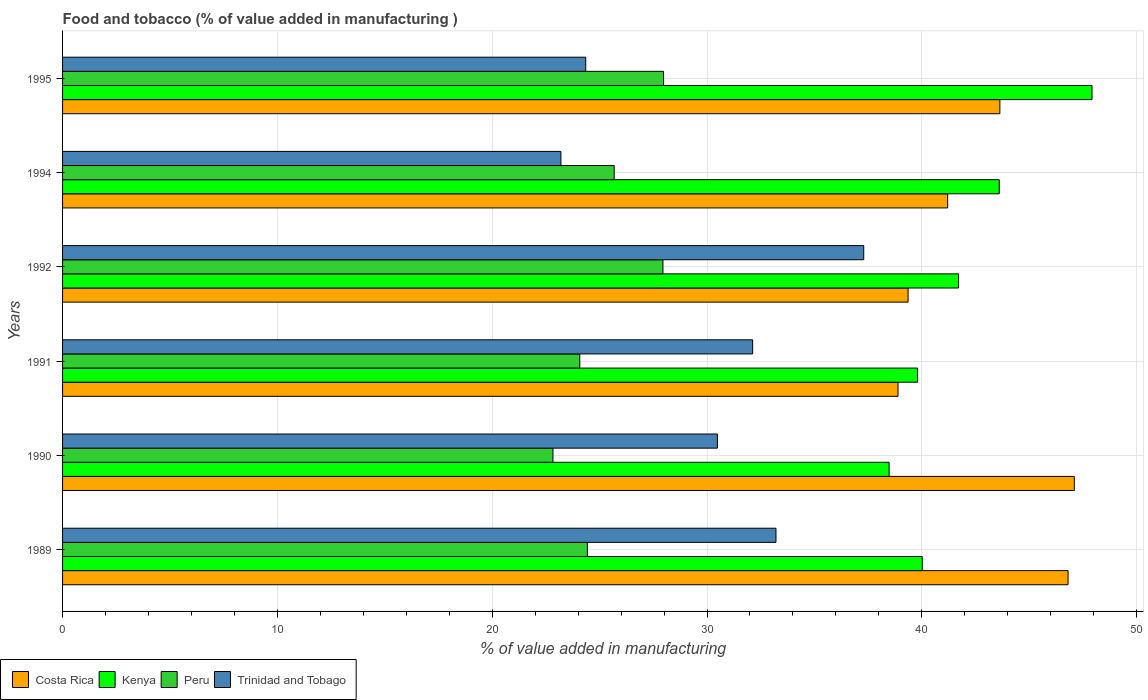How many bars are there on the 4th tick from the bottom?
Keep it short and to the point. 4. What is the label of the 1st group of bars from the top?
Your answer should be very brief. 1995. What is the value added in manufacturing food and tobacco in Trinidad and Tobago in 1989?
Provide a succinct answer. 33.21. Across all years, what is the maximum value added in manufacturing food and tobacco in Peru?
Offer a very short reply. 27.98. Across all years, what is the minimum value added in manufacturing food and tobacco in Peru?
Provide a short and direct response. 22.83. In which year was the value added in manufacturing food and tobacco in Peru minimum?
Your answer should be very brief. 1990. What is the total value added in manufacturing food and tobacco in Trinidad and Tobago in the graph?
Offer a terse response. 180.67. What is the difference between the value added in manufacturing food and tobacco in Costa Rica in 1991 and that in 1994?
Your answer should be very brief. -2.31. What is the difference between the value added in manufacturing food and tobacco in Kenya in 1991 and the value added in manufacturing food and tobacco in Trinidad and Tobago in 1989?
Make the answer very short. 6.59. What is the average value added in manufacturing food and tobacco in Peru per year?
Your response must be concise. 25.49. In the year 1995, what is the difference between the value added in manufacturing food and tobacco in Costa Rica and value added in manufacturing food and tobacco in Peru?
Offer a terse response. 15.66. What is the ratio of the value added in manufacturing food and tobacco in Costa Rica in 1992 to that in 1994?
Offer a very short reply. 0.96. Is the value added in manufacturing food and tobacco in Costa Rica in 1990 less than that in 1992?
Your answer should be very brief. No. Is the difference between the value added in manufacturing food and tobacco in Costa Rica in 1990 and 1995 greater than the difference between the value added in manufacturing food and tobacco in Peru in 1990 and 1995?
Offer a very short reply. Yes. What is the difference between the highest and the second highest value added in manufacturing food and tobacco in Peru?
Offer a terse response. 0.03. What is the difference between the highest and the lowest value added in manufacturing food and tobacco in Peru?
Offer a terse response. 5.15. In how many years, is the value added in manufacturing food and tobacco in Kenya greater than the average value added in manufacturing food and tobacco in Kenya taken over all years?
Your response must be concise. 2. Is the sum of the value added in manufacturing food and tobacco in Peru in 1992 and 1994 greater than the maximum value added in manufacturing food and tobacco in Costa Rica across all years?
Offer a very short reply. Yes. Is it the case that in every year, the sum of the value added in manufacturing food and tobacco in Costa Rica and value added in manufacturing food and tobacco in Trinidad and Tobago is greater than the sum of value added in manufacturing food and tobacco in Kenya and value added in manufacturing food and tobacco in Peru?
Give a very brief answer. Yes. What does the 4th bar from the top in 1995 represents?
Provide a succinct answer. Costa Rica. What does the 1st bar from the bottom in 1995 represents?
Your response must be concise. Costa Rica. Is it the case that in every year, the sum of the value added in manufacturing food and tobacco in Costa Rica and value added in manufacturing food and tobacco in Trinidad and Tobago is greater than the value added in manufacturing food and tobacco in Peru?
Offer a terse response. Yes. How many bars are there?
Make the answer very short. 24. Are the values on the major ticks of X-axis written in scientific E-notation?
Provide a short and direct response. No. Does the graph contain grids?
Your answer should be very brief. Yes. How many legend labels are there?
Your answer should be compact. 4. What is the title of the graph?
Ensure brevity in your answer.  Food and tobacco (% of value added in manufacturing ). Does "Other small states" appear as one of the legend labels in the graph?
Provide a succinct answer. No. What is the label or title of the X-axis?
Your answer should be compact. % of value added in manufacturing. What is the % of value added in manufacturing of Costa Rica in 1989?
Your answer should be very brief. 46.81. What is the % of value added in manufacturing of Kenya in 1989?
Ensure brevity in your answer.  40.02. What is the % of value added in manufacturing in Peru in 1989?
Keep it short and to the point. 24.43. What is the % of value added in manufacturing in Trinidad and Tobago in 1989?
Make the answer very short. 33.21. What is the % of value added in manufacturing of Costa Rica in 1990?
Make the answer very short. 47.1. What is the % of value added in manufacturing of Kenya in 1990?
Ensure brevity in your answer.  38.48. What is the % of value added in manufacturing in Peru in 1990?
Give a very brief answer. 22.83. What is the % of value added in manufacturing of Trinidad and Tobago in 1990?
Ensure brevity in your answer.  30.48. What is the % of value added in manufacturing in Costa Rica in 1991?
Give a very brief answer. 38.89. What is the % of value added in manufacturing of Kenya in 1991?
Ensure brevity in your answer.  39.8. What is the % of value added in manufacturing of Peru in 1991?
Keep it short and to the point. 24.08. What is the % of value added in manufacturing in Trinidad and Tobago in 1991?
Your answer should be compact. 32.13. What is the % of value added in manufacturing of Costa Rica in 1992?
Give a very brief answer. 39.36. What is the % of value added in manufacturing of Kenya in 1992?
Provide a succinct answer. 41.71. What is the % of value added in manufacturing in Peru in 1992?
Your answer should be compact. 27.95. What is the % of value added in manufacturing of Trinidad and Tobago in 1992?
Make the answer very short. 37.3. What is the % of value added in manufacturing in Costa Rica in 1994?
Ensure brevity in your answer.  41.2. What is the % of value added in manufacturing in Kenya in 1994?
Your answer should be compact. 43.6. What is the % of value added in manufacturing in Peru in 1994?
Offer a very short reply. 25.68. What is the % of value added in manufacturing of Trinidad and Tobago in 1994?
Make the answer very short. 23.2. What is the % of value added in manufacturing of Costa Rica in 1995?
Make the answer very short. 43.63. What is the % of value added in manufacturing of Kenya in 1995?
Keep it short and to the point. 47.92. What is the % of value added in manufacturing of Peru in 1995?
Your answer should be very brief. 27.98. What is the % of value added in manufacturing of Trinidad and Tobago in 1995?
Provide a short and direct response. 24.35. Across all years, what is the maximum % of value added in manufacturing of Costa Rica?
Offer a terse response. 47.1. Across all years, what is the maximum % of value added in manufacturing in Kenya?
Your answer should be very brief. 47.92. Across all years, what is the maximum % of value added in manufacturing of Peru?
Keep it short and to the point. 27.98. Across all years, what is the maximum % of value added in manufacturing of Trinidad and Tobago?
Ensure brevity in your answer.  37.3. Across all years, what is the minimum % of value added in manufacturing in Costa Rica?
Your answer should be compact. 38.89. Across all years, what is the minimum % of value added in manufacturing in Kenya?
Your answer should be very brief. 38.48. Across all years, what is the minimum % of value added in manufacturing in Peru?
Keep it short and to the point. 22.83. Across all years, what is the minimum % of value added in manufacturing in Trinidad and Tobago?
Ensure brevity in your answer.  23.2. What is the total % of value added in manufacturing of Costa Rica in the graph?
Offer a very short reply. 257. What is the total % of value added in manufacturing of Kenya in the graph?
Your response must be concise. 251.54. What is the total % of value added in manufacturing of Peru in the graph?
Ensure brevity in your answer.  152.94. What is the total % of value added in manufacturing of Trinidad and Tobago in the graph?
Give a very brief answer. 180.67. What is the difference between the % of value added in manufacturing of Costa Rica in 1989 and that in 1990?
Your answer should be very brief. -0.29. What is the difference between the % of value added in manufacturing of Kenya in 1989 and that in 1990?
Ensure brevity in your answer.  1.54. What is the difference between the % of value added in manufacturing in Peru in 1989 and that in 1990?
Your answer should be very brief. 1.6. What is the difference between the % of value added in manufacturing in Trinidad and Tobago in 1989 and that in 1990?
Give a very brief answer. 2.73. What is the difference between the % of value added in manufacturing in Costa Rica in 1989 and that in 1991?
Make the answer very short. 7.92. What is the difference between the % of value added in manufacturing in Kenya in 1989 and that in 1991?
Provide a short and direct response. 0.22. What is the difference between the % of value added in manufacturing of Peru in 1989 and that in 1991?
Offer a very short reply. 0.35. What is the difference between the % of value added in manufacturing of Trinidad and Tobago in 1989 and that in 1991?
Offer a terse response. 1.08. What is the difference between the % of value added in manufacturing in Costa Rica in 1989 and that in 1992?
Your answer should be very brief. 7.45. What is the difference between the % of value added in manufacturing in Kenya in 1989 and that in 1992?
Provide a short and direct response. -1.69. What is the difference between the % of value added in manufacturing of Peru in 1989 and that in 1992?
Keep it short and to the point. -3.52. What is the difference between the % of value added in manufacturing in Trinidad and Tobago in 1989 and that in 1992?
Your answer should be very brief. -4.09. What is the difference between the % of value added in manufacturing in Costa Rica in 1989 and that in 1994?
Your answer should be compact. 5.6. What is the difference between the % of value added in manufacturing in Kenya in 1989 and that in 1994?
Your response must be concise. -3.59. What is the difference between the % of value added in manufacturing of Peru in 1989 and that in 1994?
Keep it short and to the point. -1.25. What is the difference between the % of value added in manufacturing in Trinidad and Tobago in 1989 and that in 1994?
Offer a very short reply. 10.01. What is the difference between the % of value added in manufacturing in Costa Rica in 1989 and that in 1995?
Keep it short and to the point. 3.17. What is the difference between the % of value added in manufacturing of Kenya in 1989 and that in 1995?
Offer a very short reply. -7.9. What is the difference between the % of value added in manufacturing of Peru in 1989 and that in 1995?
Offer a terse response. -3.55. What is the difference between the % of value added in manufacturing in Trinidad and Tobago in 1989 and that in 1995?
Offer a very short reply. 8.86. What is the difference between the % of value added in manufacturing of Costa Rica in 1990 and that in 1991?
Keep it short and to the point. 8.21. What is the difference between the % of value added in manufacturing of Kenya in 1990 and that in 1991?
Your answer should be compact. -1.33. What is the difference between the % of value added in manufacturing of Peru in 1990 and that in 1991?
Give a very brief answer. -1.25. What is the difference between the % of value added in manufacturing in Trinidad and Tobago in 1990 and that in 1991?
Keep it short and to the point. -1.64. What is the difference between the % of value added in manufacturing in Costa Rica in 1990 and that in 1992?
Make the answer very short. 7.74. What is the difference between the % of value added in manufacturing of Kenya in 1990 and that in 1992?
Provide a short and direct response. -3.23. What is the difference between the % of value added in manufacturing in Peru in 1990 and that in 1992?
Make the answer very short. -5.12. What is the difference between the % of value added in manufacturing of Trinidad and Tobago in 1990 and that in 1992?
Your answer should be very brief. -6.81. What is the difference between the % of value added in manufacturing in Costa Rica in 1990 and that in 1994?
Keep it short and to the point. 5.89. What is the difference between the % of value added in manufacturing of Kenya in 1990 and that in 1994?
Your answer should be compact. -5.13. What is the difference between the % of value added in manufacturing of Peru in 1990 and that in 1994?
Offer a very short reply. -2.85. What is the difference between the % of value added in manufacturing in Trinidad and Tobago in 1990 and that in 1994?
Offer a very short reply. 7.29. What is the difference between the % of value added in manufacturing in Costa Rica in 1990 and that in 1995?
Provide a succinct answer. 3.46. What is the difference between the % of value added in manufacturing in Kenya in 1990 and that in 1995?
Ensure brevity in your answer.  -9.45. What is the difference between the % of value added in manufacturing in Peru in 1990 and that in 1995?
Ensure brevity in your answer.  -5.15. What is the difference between the % of value added in manufacturing of Trinidad and Tobago in 1990 and that in 1995?
Ensure brevity in your answer.  6.13. What is the difference between the % of value added in manufacturing in Costa Rica in 1991 and that in 1992?
Provide a short and direct response. -0.47. What is the difference between the % of value added in manufacturing in Kenya in 1991 and that in 1992?
Offer a very short reply. -1.91. What is the difference between the % of value added in manufacturing of Peru in 1991 and that in 1992?
Ensure brevity in your answer.  -3.87. What is the difference between the % of value added in manufacturing in Trinidad and Tobago in 1991 and that in 1992?
Make the answer very short. -5.17. What is the difference between the % of value added in manufacturing of Costa Rica in 1991 and that in 1994?
Offer a terse response. -2.31. What is the difference between the % of value added in manufacturing in Kenya in 1991 and that in 1994?
Offer a very short reply. -3.8. What is the difference between the % of value added in manufacturing of Peru in 1991 and that in 1994?
Provide a short and direct response. -1.6. What is the difference between the % of value added in manufacturing of Trinidad and Tobago in 1991 and that in 1994?
Your answer should be very brief. 8.93. What is the difference between the % of value added in manufacturing in Costa Rica in 1991 and that in 1995?
Provide a succinct answer. -4.74. What is the difference between the % of value added in manufacturing of Kenya in 1991 and that in 1995?
Offer a very short reply. -8.12. What is the difference between the % of value added in manufacturing of Peru in 1991 and that in 1995?
Keep it short and to the point. -3.9. What is the difference between the % of value added in manufacturing of Trinidad and Tobago in 1991 and that in 1995?
Offer a terse response. 7.77. What is the difference between the % of value added in manufacturing of Costa Rica in 1992 and that in 1994?
Offer a terse response. -1.84. What is the difference between the % of value added in manufacturing of Kenya in 1992 and that in 1994?
Offer a very short reply. -1.89. What is the difference between the % of value added in manufacturing in Peru in 1992 and that in 1994?
Your answer should be very brief. 2.27. What is the difference between the % of value added in manufacturing of Trinidad and Tobago in 1992 and that in 1994?
Your response must be concise. 14.1. What is the difference between the % of value added in manufacturing in Costa Rica in 1992 and that in 1995?
Offer a terse response. -4.27. What is the difference between the % of value added in manufacturing in Kenya in 1992 and that in 1995?
Provide a short and direct response. -6.21. What is the difference between the % of value added in manufacturing of Peru in 1992 and that in 1995?
Your response must be concise. -0.03. What is the difference between the % of value added in manufacturing in Trinidad and Tobago in 1992 and that in 1995?
Give a very brief answer. 12.94. What is the difference between the % of value added in manufacturing in Costa Rica in 1994 and that in 1995?
Your answer should be compact. -2.43. What is the difference between the % of value added in manufacturing of Kenya in 1994 and that in 1995?
Ensure brevity in your answer.  -4.32. What is the difference between the % of value added in manufacturing of Peru in 1994 and that in 1995?
Give a very brief answer. -2.3. What is the difference between the % of value added in manufacturing of Trinidad and Tobago in 1994 and that in 1995?
Make the answer very short. -1.16. What is the difference between the % of value added in manufacturing in Costa Rica in 1989 and the % of value added in manufacturing in Kenya in 1990?
Provide a succinct answer. 8.33. What is the difference between the % of value added in manufacturing of Costa Rica in 1989 and the % of value added in manufacturing of Peru in 1990?
Ensure brevity in your answer.  23.98. What is the difference between the % of value added in manufacturing in Costa Rica in 1989 and the % of value added in manufacturing in Trinidad and Tobago in 1990?
Keep it short and to the point. 16.32. What is the difference between the % of value added in manufacturing of Kenya in 1989 and the % of value added in manufacturing of Peru in 1990?
Provide a succinct answer. 17.19. What is the difference between the % of value added in manufacturing in Kenya in 1989 and the % of value added in manufacturing in Trinidad and Tobago in 1990?
Your response must be concise. 9.53. What is the difference between the % of value added in manufacturing in Peru in 1989 and the % of value added in manufacturing in Trinidad and Tobago in 1990?
Provide a succinct answer. -6.05. What is the difference between the % of value added in manufacturing of Costa Rica in 1989 and the % of value added in manufacturing of Kenya in 1991?
Your response must be concise. 7. What is the difference between the % of value added in manufacturing of Costa Rica in 1989 and the % of value added in manufacturing of Peru in 1991?
Give a very brief answer. 22.73. What is the difference between the % of value added in manufacturing in Costa Rica in 1989 and the % of value added in manufacturing in Trinidad and Tobago in 1991?
Make the answer very short. 14.68. What is the difference between the % of value added in manufacturing of Kenya in 1989 and the % of value added in manufacturing of Peru in 1991?
Keep it short and to the point. 15.94. What is the difference between the % of value added in manufacturing of Kenya in 1989 and the % of value added in manufacturing of Trinidad and Tobago in 1991?
Give a very brief answer. 7.89. What is the difference between the % of value added in manufacturing of Peru in 1989 and the % of value added in manufacturing of Trinidad and Tobago in 1991?
Keep it short and to the point. -7.7. What is the difference between the % of value added in manufacturing of Costa Rica in 1989 and the % of value added in manufacturing of Kenya in 1992?
Ensure brevity in your answer.  5.1. What is the difference between the % of value added in manufacturing in Costa Rica in 1989 and the % of value added in manufacturing in Peru in 1992?
Provide a short and direct response. 18.86. What is the difference between the % of value added in manufacturing of Costa Rica in 1989 and the % of value added in manufacturing of Trinidad and Tobago in 1992?
Make the answer very short. 9.51. What is the difference between the % of value added in manufacturing of Kenya in 1989 and the % of value added in manufacturing of Peru in 1992?
Offer a very short reply. 12.07. What is the difference between the % of value added in manufacturing in Kenya in 1989 and the % of value added in manufacturing in Trinidad and Tobago in 1992?
Ensure brevity in your answer.  2.72. What is the difference between the % of value added in manufacturing of Peru in 1989 and the % of value added in manufacturing of Trinidad and Tobago in 1992?
Your answer should be compact. -12.87. What is the difference between the % of value added in manufacturing in Costa Rica in 1989 and the % of value added in manufacturing in Kenya in 1994?
Give a very brief answer. 3.2. What is the difference between the % of value added in manufacturing of Costa Rica in 1989 and the % of value added in manufacturing of Peru in 1994?
Offer a very short reply. 21.13. What is the difference between the % of value added in manufacturing in Costa Rica in 1989 and the % of value added in manufacturing in Trinidad and Tobago in 1994?
Make the answer very short. 23.61. What is the difference between the % of value added in manufacturing in Kenya in 1989 and the % of value added in manufacturing in Peru in 1994?
Make the answer very short. 14.34. What is the difference between the % of value added in manufacturing in Kenya in 1989 and the % of value added in manufacturing in Trinidad and Tobago in 1994?
Ensure brevity in your answer.  16.82. What is the difference between the % of value added in manufacturing in Peru in 1989 and the % of value added in manufacturing in Trinidad and Tobago in 1994?
Your answer should be very brief. 1.23. What is the difference between the % of value added in manufacturing of Costa Rica in 1989 and the % of value added in manufacturing of Kenya in 1995?
Offer a terse response. -1.12. What is the difference between the % of value added in manufacturing of Costa Rica in 1989 and the % of value added in manufacturing of Peru in 1995?
Ensure brevity in your answer.  18.83. What is the difference between the % of value added in manufacturing of Costa Rica in 1989 and the % of value added in manufacturing of Trinidad and Tobago in 1995?
Your answer should be very brief. 22.45. What is the difference between the % of value added in manufacturing in Kenya in 1989 and the % of value added in manufacturing in Peru in 1995?
Provide a short and direct response. 12.04. What is the difference between the % of value added in manufacturing of Kenya in 1989 and the % of value added in manufacturing of Trinidad and Tobago in 1995?
Offer a terse response. 15.66. What is the difference between the % of value added in manufacturing in Peru in 1989 and the % of value added in manufacturing in Trinidad and Tobago in 1995?
Make the answer very short. 0.07. What is the difference between the % of value added in manufacturing of Costa Rica in 1990 and the % of value added in manufacturing of Kenya in 1991?
Offer a very short reply. 7.29. What is the difference between the % of value added in manufacturing of Costa Rica in 1990 and the % of value added in manufacturing of Peru in 1991?
Your answer should be compact. 23.02. What is the difference between the % of value added in manufacturing in Costa Rica in 1990 and the % of value added in manufacturing in Trinidad and Tobago in 1991?
Give a very brief answer. 14.97. What is the difference between the % of value added in manufacturing in Kenya in 1990 and the % of value added in manufacturing in Trinidad and Tobago in 1991?
Make the answer very short. 6.35. What is the difference between the % of value added in manufacturing of Peru in 1990 and the % of value added in manufacturing of Trinidad and Tobago in 1991?
Offer a very short reply. -9.3. What is the difference between the % of value added in manufacturing of Costa Rica in 1990 and the % of value added in manufacturing of Kenya in 1992?
Offer a terse response. 5.39. What is the difference between the % of value added in manufacturing of Costa Rica in 1990 and the % of value added in manufacturing of Peru in 1992?
Keep it short and to the point. 19.15. What is the difference between the % of value added in manufacturing of Costa Rica in 1990 and the % of value added in manufacturing of Trinidad and Tobago in 1992?
Your response must be concise. 9.8. What is the difference between the % of value added in manufacturing in Kenya in 1990 and the % of value added in manufacturing in Peru in 1992?
Ensure brevity in your answer.  10.53. What is the difference between the % of value added in manufacturing of Kenya in 1990 and the % of value added in manufacturing of Trinidad and Tobago in 1992?
Your answer should be compact. 1.18. What is the difference between the % of value added in manufacturing of Peru in 1990 and the % of value added in manufacturing of Trinidad and Tobago in 1992?
Give a very brief answer. -14.47. What is the difference between the % of value added in manufacturing in Costa Rica in 1990 and the % of value added in manufacturing in Kenya in 1994?
Your answer should be compact. 3.49. What is the difference between the % of value added in manufacturing of Costa Rica in 1990 and the % of value added in manufacturing of Peru in 1994?
Your answer should be very brief. 21.42. What is the difference between the % of value added in manufacturing in Costa Rica in 1990 and the % of value added in manufacturing in Trinidad and Tobago in 1994?
Give a very brief answer. 23.9. What is the difference between the % of value added in manufacturing in Kenya in 1990 and the % of value added in manufacturing in Peru in 1994?
Offer a very short reply. 12.8. What is the difference between the % of value added in manufacturing in Kenya in 1990 and the % of value added in manufacturing in Trinidad and Tobago in 1994?
Offer a very short reply. 15.28. What is the difference between the % of value added in manufacturing in Peru in 1990 and the % of value added in manufacturing in Trinidad and Tobago in 1994?
Ensure brevity in your answer.  -0.37. What is the difference between the % of value added in manufacturing of Costa Rica in 1990 and the % of value added in manufacturing of Kenya in 1995?
Your response must be concise. -0.83. What is the difference between the % of value added in manufacturing in Costa Rica in 1990 and the % of value added in manufacturing in Peru in 1995?
Keep it short and to the point. 19.12. What is the difference between the % of value added in manufacturing in Costa Rica in 1990 and the % of value added in manufacturing in Trinidad and Tobago in 1995?
Provide a succinct answer. 22.74. What is the difference between the % of value added in manufacturing in Kenya in 1990 and the % of value added in manufacturing in Peru in 1995?
Ensure brevity in your answer.  10.5. What is the difference between the % of value added in manufacturing of Kenya in 1990 and the % of value added in manufacturing of Trinidad and Tobago in 1995?
Provide a short and direct response. 14.12. What is the difference between the % of value added in manufacturing in Peru in 1990 and the % of value added in manufacturing in Trinidad and Tobago in 1995?
Give a very brief answer. -1.53. What is the difference between the % of value added in manufacturing of Costa Rica in 1991 and the % of value added in manufacturing of Kenya in 1992?
Offer a terse response. -2.82. What is the difference between the % of value added in manufacturing of Costa Rica in 1991 and the % of value added in manufacturing of Peru in 1992?
Your answer should be compact. 10.94. What is the difference between the % of value added in manufacturing of Costa Rica in 1991 and the % of value added in manufacturing of Trinidad and Tobago in 1992?
Offer a very short reply. 1.6. What is the difference between the % of value added in manufacturing of Kenya in 1991 and the % of value added in manufacturing of Peru in 1992?
Provide a short and direct response. 11.85. What is the difference between the % of value added in manufacturing of Kenya in 1991 and the % of value added in manufacturing of Trinidad and Tobago in 1992?
Offer a very short reply. 2.51. What is the difference between the % of value added in manufacturing in Peru in 1991 and the % of value added in manufacturing in Trinidad and Tobago in 1992?
Offer a terse response. -13.22. What is the difference between the % of value added in manufacturing in Costa Rica in 1991 and the % of value added in manufacturing in Kenya in 1994?
Provide a succinct answer. -4.71. What is the difference between the % of value added in manufacturing of Costa Rica in 1991 and the % of value added in manufacturing of Peru in 1994?
Offer a terse response. 13.21. What is the difference between the % of value added in manufacturing of Costa Rica in 1991 and the % of value added in manufacturing of Trinidad and Tobago in 1994?
Provide a short and direct response. 15.69. What is the difference between the % of value added in manufacturing of Kenya in 1991 and the % of value added in manufacturing of Peru in 1994?
Offer a terse response. 14.12. What is the difference between the % of value added in manufacturing of Kenya in 1991 and the % of value added in manufacturing of Trinidad and Tobago in 1994?
Offer a very short reply. 16.6. What is the difference between the % of value added in manufacturing in Peru in 1991 and the % of value added in manufacturing in Trinidad and Tobago in 1994?
Provide a succinct answer. 0.88. What is the difference between the % of value added in manufacturing of Costa Rica in 1991 and the % of value added in manufacturing of Kenya in 1995?
Give a very brief answer. -9.03. What is the difference between the % of value added in manufacturing of Costa Rica in 1991 and the % of value added in manufacturing of Peru in 1995?
Offer a terse response. 10.91. What is the difference between the % of value added in manufacturing of Costa Rica in 1991 and the % of value added in manufacturing of Trinidad and Tobago in 1995?
Provide a short and direct response. 14.54. What is the difference between the % of value added in manufacturing in Kenya in 1991 and the % of value added in manufacturing in Peru in 1995?
Offer a very short reply. 11.83. What is the difference between the % of value added in manufacturing in Kenya in 1991 and the % of value added in manufacturing in Trinidad and Tobago in 1995?
Provide a succinct answer. 15.45. What is the difference between the % of value added in manufacturing in Peru in 1991 and the % of value added in manufacturing in Trinidad and Tobago in 1995?
Offer a very short reply. -0.28. What is the difference between the % of value added in manufacturing in Costa Rica in 1992 and the % of value added in manufacturing in Kenya in 1994?
Your answer should be compact. -4.24. What is the difference between the % of value added in manufacturing of Costa Rica in 1992 and the % of value added in manufacturing of Peru in 1994?
Make the answer very short. 13.68. What is the difference between the % of value added in manufacturing in Costa Rica in 1992 and the % of value added in manufacturing in Trinidad and Tobago in 1994?
Keep it short and to the point. 16.16. What is the difference between the % of value added in manufacturing in Kenya in 1992 and the % of value added in manufacturing in Peru in 1994?
Offer a very short reply. 16.03. What is the difference between the % of value added in manufacturing in Kenya in 1992 and the % of value added in manufacturing in Trinidad and Tobago in 1994?
Provide a succinct answer. 18.51. What is the difference between the % of value added in manufacturing in Peru in 1992 and the % of value added in manufacturing in Trinidad and Tobago in 1994?
Offer a terse response. 4.75. What is the difference between the % of value added in manufacturing of Costa Rica in 1992 and the % of value added in manufacturing of Kenya in 1995?
Provide a succinct answer. -8.56. What is the difference between the % of value added in manufacturing of Costa Rica in 1992 and the % of value added in manufacturing of Peru in 1995?
Your response must be concise. 11.38. What is the difference between the % of value added in manufacturing of Costa Rica in 1992 and the % of value added in manufacturing of Trinidad and Tobago in 1995?
Your response must be concise. 15.01. What is the difference between the % of value added in manufacturing in Kenya in 1992 and the % of value added in manufacturing in Peru in 1995?
Your response must be concise. 13.73. What is the difference between the % of value added in manufacturing of Kenya in 1992 and the % of value added in manufacturing of Trinidad and Tobago in 1995?
Your answer should be very brief. 17.36. What is the difference between the % of value added in manufacturing in Peru in 1992 and the % of value added in manufacturing in Trinidad and Tobago in 1995?
Your answer should be very brief. 3.59. What is the difference between the % of value added in manufacturing in Costa Rica in 1994 and the % of value added in manufacturing in Kenya in 1995?
Your answer should be compact. -6.72. What is the difference between the % of value added in manufacturing in Costa Rica in 1994 and the % of value added in manufacturing in Peru in 1995?
Your answer should be very brief. 13.23. What is the difference between the % of value added in manufacturing of Costa Rica in 1994 and the % of value added in manufacturing of Trinidad and Tobago in 1995?
Make the answer very short. 16.85. What is the difference between the % of value added in manufacturing of Kenya in 1994 and the % of value added in manufacturing of Peru in 1995?
Offer a terse response. 15.63. What is the difference between the % of value added in manufacturing of Kenya in 1994 and the % of value added in manufacturing of Trinidad and Tobago in 1995?
Your answer should be very brief. 19.25. What is the difference between the % of value added in manufacturing in Peru in 1994 and the % of value added in manufacturing in Trinidad and Tobago in 1995?
Provide a short and direct response. 1.32. What is the average % of value added in manufacturing in Costa Rica per year?
Ensure brevity in your answer.  42.83. What is the average % of value added in manufacturing in Kenya per year?
Provide a succinct answer. 41.92. What is the average % of value added in manufacturing of Peru per year?
Provide a short and direct response. 25.49. What is the average % of value added in manufacturing in Trinidad and Tobago per year?
Your response must be concise. 30.11. In the year 1989, what is the difference between the % of value added in manufacturing of Costa Rica and % of value added in manufacturing of Kenya?
Offer a terse response. 6.79. In the year 1989, what is the difference between the % of value added in manufacturing in Costa Rica and % of value added in manufacturing in Peru?
Make the answer very short. 22.38. In the year 1989, what is the difference between the % of value added in manufacturing of Costa Rica and % of value added in manufacturing of Trinidad and Tobago?
Offer a very short reply. 13.6. In the year 1989, what is the difference between the % of value added in manufacturing of Kenya and % of value added in manufacturing of Peru?
Your response must be concise. 15.59. In the year 1989, what is the difference between the % of value added in manufacturing of Kenya and % of value added in manufacturing of Trinidad and Tobago?
Offer a very short reply. 6.81. In the year 1989, what is the difference between the % of value added in manufacturing of Peru and % of value added in manufacturing of Trinidad and Tobago?
Make the answer very short. -8.78. In the year 1990, what is the difference between the % of value added in manufacturing in Costa Rica and % of value added in manufacturing in Kenya?
Provide a short and direct response. 8.62. In the year 1990, what is the difference between the % of value added in manufacturing in Costa Rica and % of value added in manufacturing in Peru?
Provide a succinct answer. 24.27. In the year 1990, what is the difference between the % of value added in manufacturing of Costa Rica and % of value added in manufacturing of Trinidad and Tobago?
Offer a very short reply. 16.61. In the year 1990, what is the difference between the % of value added in manufacturing of Kenya and % of value added in manufacturing of Peru?
Offer a terse response. 15.65. In the year 1990, what is the difference between the % of value added in manufacturing in Kenya and % of value added in manufacturing in Trinidad and Tobago?
Keep it short and to the point. 7.99. In the year 1990, what is the difference between the % of value added in manufacturing of Peru and % of value added in manufacturing of Trinidad and Tobago?
Provide a succinct answer. -7.66. In the year 1991, what is the difference between the % of value added in manufacturing of Costa Rica and % of value added in manufacturing of Kenya?
Provide a succinct answer. -0.91. In the year 1991, what is the difference between the % of value added in manufacturing in Costa Rica and % of value added in manufacturing in Peru?
Provide a short and direct response. 14.81. In the year 1991, what is the difference between the % of value added in manufacturing in Costa Rica and % of value added in manufacturing in Trinidad and Tobago?
Provide a short and direct response. 6.77. In the year 1991, what is the difference between the % of value added in manufacturing of Kenya and % of value added in manufacturing of Peru?
Provide a succinct answer. 15.73. In the year 1991, what is the difference between the % of value added in manufacturing in Kenya and % of value added in manufacturing in Trinidad and Tobago?
Offer a terse response. 7.68. In the year 1991, what is the difference between the % of value added in manufacturing of Peru and % of value added in manufacturing of Trinidad and Tobago?
Provide a succinct answer. -8.05. In the year 1992, what is the difference between the % of value added in manufacturing of Costa Rica and % of value added in manufacturing of Kenya?
Provide a succinct answer. -2.35. In the year 1992, what is the difference between the % of value added in manufacturing in Costa Rica and % of value added in manufacturing in Peru?
Make the answer very short. 11.41. In the year 1992, what is the difference between the % of value added in manufacturing in Costa Rica and % of value added in manufacturing in Trinidad and Tobago?
Provide a short and direct response. 2.06. In the year 1992, what is the difference between the % of value added in manufacturing of Kenya and % of value added in manufacturing of Peru?
Offer a terse response. 13.76. In the year 1992, what is the difference between the % of value added in manufacturing of Kenya and % of value added in manufacturing of Trinidad and Tobago?
Ensure brevity in your answer.  4.42. In the year 1992, what is the difference between the % of value added in manufacturing of Peru and % of value added in manufacturing of Trinidad and Tobago?
Provide a succinct answer. -9.35. In the year 1994, what is the difference between the % of value added in manufacturing in Costa Rica and % of value added in manufacturing in Kenya?
Your response must be concise. -2.4. In the year 1994, what is the difference between the % of value added in manufacturing in Costa Rica and % of value added in manufacturing in Peru?
Offer a very short reply. 15.52. In the year 1994, what is the difference between the % of value added in manufacturing of Costa Rica and % of value added in manufacturing of Trinidad and Tobago?
Your response must be concise. 18. In the year 1994, what is the difference between the % of value added in manufacturing of Kenya and % of value added in manufacturing of Peru?
Give a very brief answer. 17.93. In the year 1994, what is the difference between the % of value added in manufacturing in Kenya and % of value added in manufacturing in Trinidad and Tobago?
Provide a succinct answer. 20.41. In the year 1994, what is the difference between the % of value added in manufacturing in Peru and % of value added in manufacturing in Trinidad and Tobago?
Provide a succinct answer. 2.48. In the year 1995, what is the difference between the % of value added in manufacturing in Costa Rica and % of value added in manufacturing in Kenya?
Provide a succinct answer. -4.29. In the year 1995, what is the difference between the % of value added in manufacturing in Costa Rica and % of value added in manufacturing in Peru?
Offer a terse response. 15.66. In the year 1995, what is the difference between the % of value added in manufacturing of Costa Rica and % of value added in manufacturing of Trinidad and Tobago?
Provide a short and direct response. 19.28. In the year 1995, what is the difference between the % of value added in manufacturing in Kenya and % of value added in manufacturing in Peru?
Ensure brevity in your answer.  19.95. In the year 1995, what is the difference between the % of value added in manufacturing in Kenya and % of value added in manufacturing in Trinidad and Tobago?
Give a very brief answer. 23.57. In the year 1995, what is the difference between the % of value added in manufacturing of Peru and % of value added in manufacturing of Trinidad and Tobago?
Provide a succinct answer. 3.62. What is the ratio of the % of value added in manufacturing in Kenya in 1989 to that in 1990?
Keep it short and to the point. 1.04. What is the ratio of the % of value added in manufacturing in Peru in 1989 to that in 1990?
Provide a short and direct response. 1.07. What is the ratio of the % of value added in manufacturing of Trinidad and Tobago in 1989 to that in 1990?
Provide a succinct answer. 1.09. What is the ratio of the % of value added in manufacturing of Costa Rica in 1989 to that in 1991?
Give a very brief answer. 1.2. What is the ratio of the % of value added in manufacturing of Kenya in 1989 to that in 1991?
Your answer should be compact. 1.01. What is the ratio of the % of value added in manufacturing in Peru in 1989 to that in 1991?
Your response must be concise. 1.01. What is the ratio of the % of value added in manufacturing of Trinidad and Tobago in 1989 to that in 1991?
Make the answer very short. 1.03. What is the ratio of the % of value added in manufacturing of Costa Rica in 1989 to that in 1992?
Give a very brief answer. 1.19. What is the ratio of the % of value added in manufacturing in Kenya in 1989 to that in 1992?
Offer a terse response. 0.96. What is the ratio of the % of value added in manufacturing of Peru in 1989 to that in 1992?
Your answer should be very brief. 0.87. What is the ratio of the % of value added in manufacturing of Trinidad and Tobago in 1989 to that in 1992?
Offer a very short reply. 0.89. What is the ratio of the % of value added in manufacturing of Costa Rica in 1989 to that in 1994?
Offer a terse response. 1.14. What is the ratio of the % of value added in manufacturing in Kenya in 1989 to that in 1994?
Offer a terse response. 0.92. What is the ratio of the % of value added in manufacturing in Peru in 1989 to that in 1994?
Offer a very short reply. 0.95. What is the ratio of the % of value added in manufacturing in Trinidad and Tobago in 1989 to that in 1994?
Offer a terse response. 1.43. What is the ratio of the % of value added in manufacturing of Costa Rica in 1989 to that in 1995?
Provide a short and direct response. 1.07. What is the ratio of the % of value added in manufacturing in Kenya in 1989 to that in 1995?
Make the answer very short. 0.84. What is the ratio of the % of value added in manufacturing in Peru in 1989 to that in 1995?
Keep it short and to the point. 0.87. What is the ratio of the % of value added in manufacturing in Trinidad and Tobago in 1989 to that in 1995?
Your response must be concise. 1.36. What is the ratio of the % of value added in manufacturing in Costa Rica in 1990 to that in 1991?
Make the answer very short. 1.21. What is the ratio of the % of value added in manufacturing of Kenya in 1990 to that in 1991?
Provide a succinct answer. 0.97. What is the ratio of the % of value added in manufacturing in Peru in 1990 to that in 1991?
Offer a very short reply. 0.95. What is the ratio of the % of value added in manufacturing of Trinidad and Tobago in 1990 to that in 1991?
Ensure brevity in your answer.  0.95. What is the ratio of the % of value added in manufacturing of Costa Rica in 1990 to that in 1992?
Provide a succinct answer. 1.2. What is the ratio of the % of value added in manufacturing in Kenya in 1990 to that in 1992?
Your answer should be very brief. 0.92. What is the ratio of the % of value added in manufacturing in Peru in 1990 to that in 1992?
Ensure brevity in your answer.  0.82. What is the ratio of the % of value added in manufacturing of Trinidad and Tobago in 1990 to that in 1992?
Your answer should be very brief. 0.82. What is the ratio of the % of value added in manufacturing of Costa Rica in 1990 to that in 1994?
Offer a very short reply. 1.14. What is the ratio of the % of value added in manufacturing of Kenya in 1990 to that in 1994?
Offer a very short reply. 0.88. What is the ratio of the % of value added in manufacturing of Peru in 1990 to that in 1994?
Keep it short and to the point. 0.89. What is the ratio of the % of value added in manufacturing of Trinidad and Tobago in 1990 to that in 1994?
Your answer should be compact. 1.31. What is the ratio of the % of value added in manufacturing in Costa Rica in 1990 to that in 1995?
Give a very brief answer. 1.08. What is the ratio of the % of value added in manufacturing of Kenya in 1990 to that in 1995?
Give a very brief answer. 0.8. What is the ratio of the % of value added in manufacturing in Peru in 1990 to that in 1995?
Offer a very short reply. 0.82. What is the ratio of the % of value added in manufacturing in Trinidad and Tobago in 1990 to that in 1995?
Provide a short and direct response. 1.25. What is the ratio of the % of value added in manufacturing in Kenya in 1991 to that in 1992?
Give a very brief answer. 0.95. What is the ratio of the % of value added in manufacturing in Peru in 1991 to that in 1992?
Provide a short and direct response. 0.86. What is the ratio of the % of value added in manufacturing of Trinidad and Tobago in 1991 to that in 1992?
Your answer should be compact. 0.86. What is the ratio of the % of value added in manufacturing in Costa Rica in 1991 to that in 1994?
Give a very brief answer. 0.94. What is the ratio of the % of value added in manufacturing in Kenya in 1991 to that in 1994?
Give a very brief answer. 0.91. What is the ratio of the % of value added in manufacturing in Peru in 1991 to that in 1994?
Provide a succinct answer. 0.94. What is the ratio of the % of value added in manufacturing in Trinidad and Tobago in 1991 to that in 1994?
Your answer should be compact. 1.38. What is the ratio of the % of value added in manufacturing in Costa Rica in 1991 to that in 1995?
Make the answer very short. 0.89. What is the ratio of the % of value added in manufacturing of Kenya in 1991 to that in 1995?
Offer a very short reply. 0.83. What is the ratio of the % of value added in manufacturing of Peru in 1991 to that in 1995?
Keep it short and to the point. 0.86. What is the ratio of the % of value added in manufacturing of Trinidad and Tobago in 1991 to that in 1995?
Make the answer very short. 1.32. What is the ratio of the % of value added in manufacturing of Costa Rica in 1992 to that in 1994?
Make the answer very short. 0.96. What is the ratio of the % of value added in manufacturing in Kenya in 1992 to that in 1994?
Make the answer very short. 0.96. What is the ratio of the % of value added in manufacturing in Peru in 1992 to that in 1994?
Offer a terse response. 1.09. What is the ratio of the % of value added in manufacturing in Trinidad and Tobago in 1992 to that in 1994?
Ensure brevity in your answer.  1.61. What is the ratio of the % of value added in manufacturing of Costa Rica in 1992 to that in 1995?
Offer a terse response. 0.9. What is the ratio of the % of value added in manufacturing of Kenya in 1992 to that in 1995?
Make the answer very short. 0.87. What is the ratio of the % of value added in manufacturing of Trinidad and Tobago in 1992 to that in 1995?
Provide a succinct answer. 1.53. What is the ratio of the % of value added in manufacturing in Costa Rica in 1994 to that in 1995?
Give a very brief answer. 0.94. What is the ratio of the % of value added in manufacturing in Kenya in 1994 to that in 1995?
Your answer should be very brief. 0.91. What is the ratio of the % of value added in manufacturing in Peru in 1994 to that in 1995?
Ensure brevity in your answer.  0.92. What is the ratio of the % of value added in manufacturing of Trinidad and Tobago in 1994 to that in 1995?
Your answer should be very brief. 0.95. What is the difference between the highest and the second highest % of value added in manufacturing in Costa Rica?
Provide a short and direct response. 0.29. What is the difference between the highest and the second highest % of value added in manufacturing in Kenya?
Offer a terse response. 4.32. What is the difference between the highest and the second highest % of value added in manufacturing of Peru?
Your response must be concise. 0.03. What is the difference between the highest and the second highest % of value added in manufacturing of Trinidad and Tobago?
Your response must be concise. 4.09. What is the difference between the highest and the lowest % of value added in manufacturing of Costa Rica?
Offer a terse response. 8.21. What is the difference between the highest and the lowest % of value added in manufacturing of Kenya?
Your answer should be very brief. 9.45. What is the difference between the highest and the lowest % of value added in manufacturing of Peru?
Your response must be concise. 5.15. What is the difference between the highest and the lowest % of value added in manufacturing of Trinidad and Tobago?
Keep it short and to the point. 14.1. 